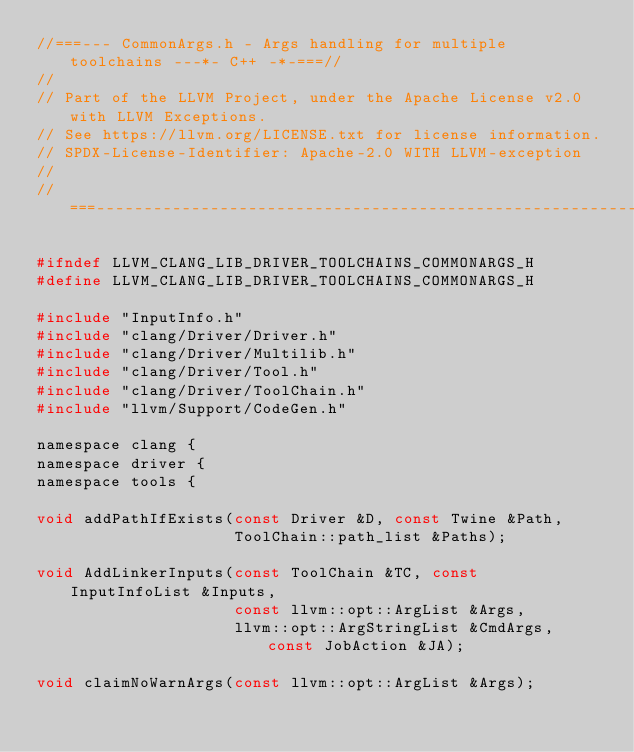Convert code to text. <code><loc_0><loc_0><loc_500><loc_500><_C_>//===--- CommonArgs.h - Args handling for multiple toolchains ---*- C++ -*-===//
//
// Part of the LLVM Project, under the Apache License v2.0 with LLVM Exceptions.
// See https://llvm.org/LICENSE.txt for license information.
// SPDX-License-Identifier: Apache-2.0 WITH LLVM-exception
//
//===----------------------------------------------------------------------===//

#ifndef LLVM_CLANG_LIB_DRIVER_TOOLCHAINS_COMMONARGS_H
#define LLVM_CLANG_LIB_DRIVER_TOOLCHAINS_COMMONARGS_H

#include "InputInfo.h"
#include "clang/Driver/Driver.h"
#include "clang/Driver/Multilib.h"
#include "clang/Driver/Tool.h"
#include "clang/Driver/ToolChain.h"
#include "llvm/Support/CodeGen.h"

namespace clang {
namespace driver {
namespace tools {

void addPathIfExists(const Driver &D, const Twine &Path,
                     ToolChain::path_list &Paths);

void AddLinkerInputs(const ToolChain &TC, const InputInfoList &Inputs,
                     const llvm::opt::ArgList &Args,
                     llvm::opt::ArgStringList &CmdArgs, const JobAction &JA);

void claimNoWarnArgs(const llvm::opt::ArgList &Args);
</code> 